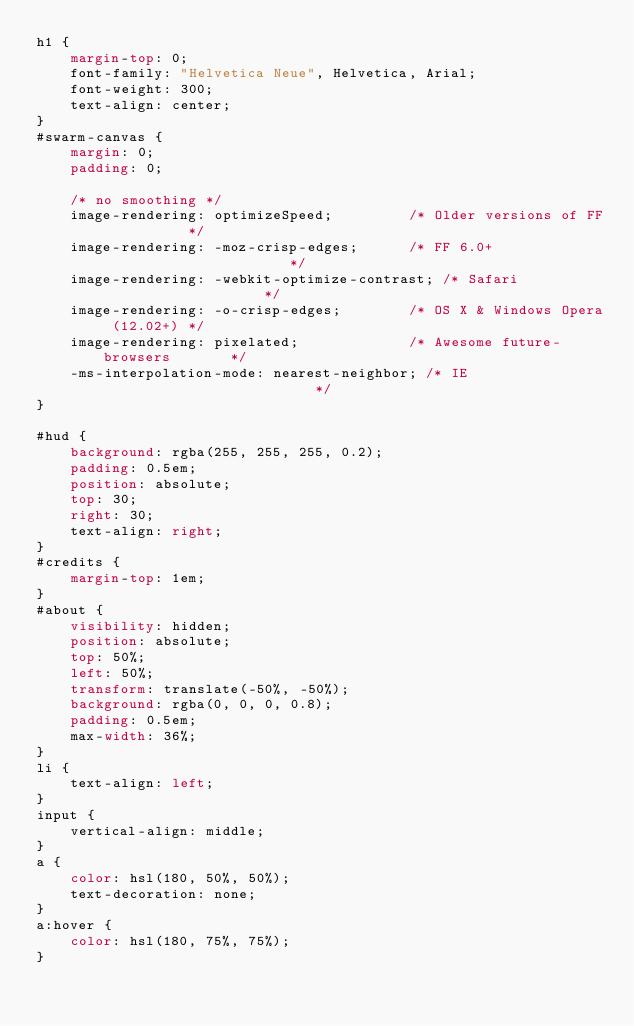Convert code to text. <code><loc_0><loc_0><loc_500><loc_500><_CSS_>h1 {
    margin-top: 0;
    font-family: "Helvetica Neue", Helvetica, Arial;
    font-weight: 300;
    text-align: center;
}
#swarm-canvas {
    margin: 0;
    padding: 0;

    /* no smoothing */
    image-rendering: optimizeSpeed;         /* Older versions of FF          */
    image-rendering: -moz-crisp-edges;      /* FF 6.0+                       */
    image-rendering: -webkit-optimize-contrast; /* Safari                    */
    image-rendering: -o-crisp-edges;        /* OS X & Windows Opera (12.02+) */
    image-rendering: pixelated;             /* Awesome future-browsers       */
    -ms-interpolation-mode: nearest-neighbor; /* IE                          */
}

#hud {
    background: rgba(255, 255, 255, 0.2);
    padding: 0.5em;
    position: absolute;
    top: 30;
    right: 30;
    text-align: right;
}
#credits {
    margin-top: 1em;
}
#about {
    visibility: hidden;
    position: absolute;
    top: 50%;
    left: 50%;
    transform: translate(-50%, -50%);
    background: rgba(0, 0, 0, 0.8);
    padding: 0.5em;
    max-width: 36%;
}
li {
    text-align: left;
}
input {
    vertical-align: middle;
}
a {
    color: hsl(180, 50%, 50%);
    text-decoration: none;
}
a:hover {
    color: hsl(180, 75%, 75%);
}</code> 